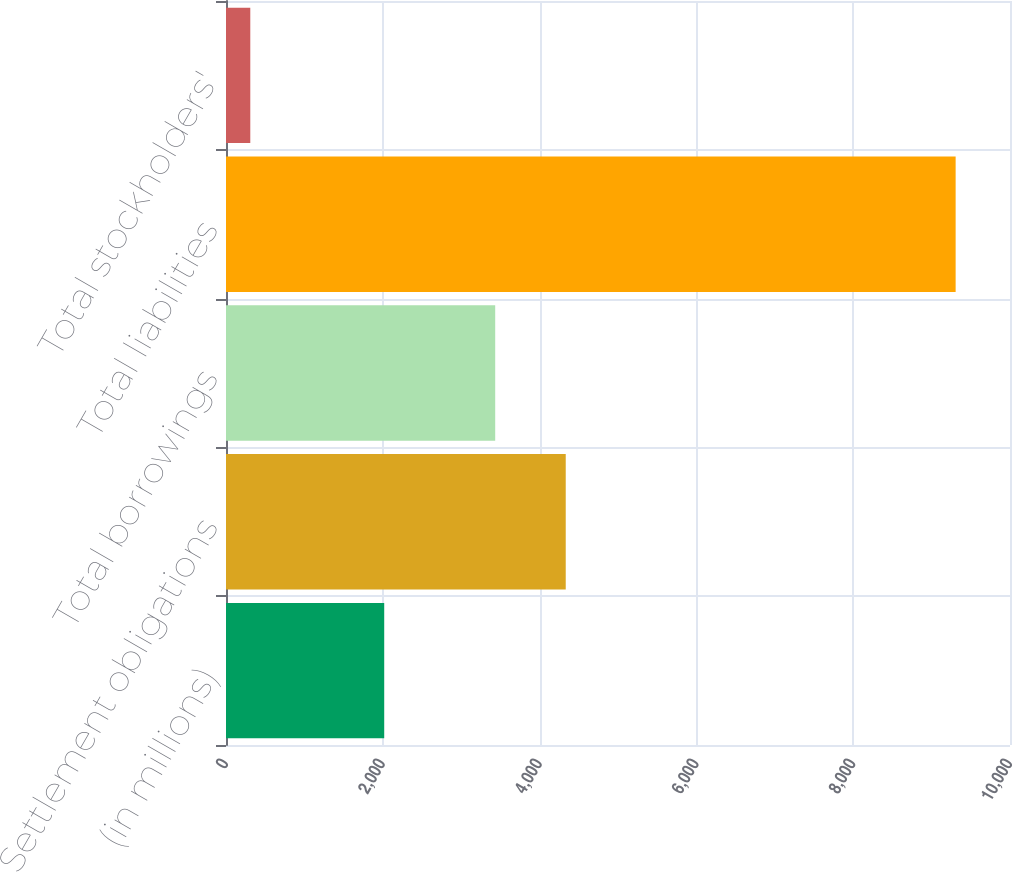<chart> <loc_0><loc_0><loc_500><loc_500><bar_chart><fcel>(in millions)<fcel>Settlement obligations<fcel>Total borrowings<fcel>Total liabilities<fcel>Total stockholders'<nl><fcel>2018<fcel>4333.38<fcel>3433.7<fcel>9306.6<fcel>309.8<nl></chart> 